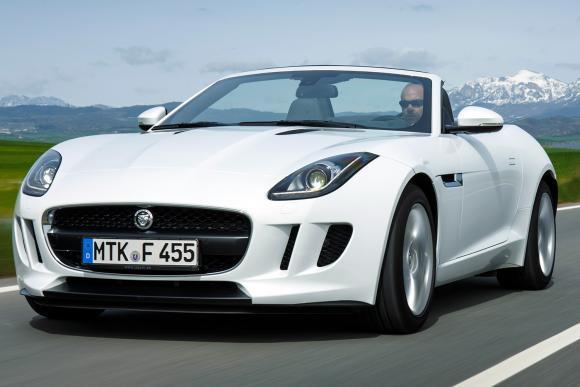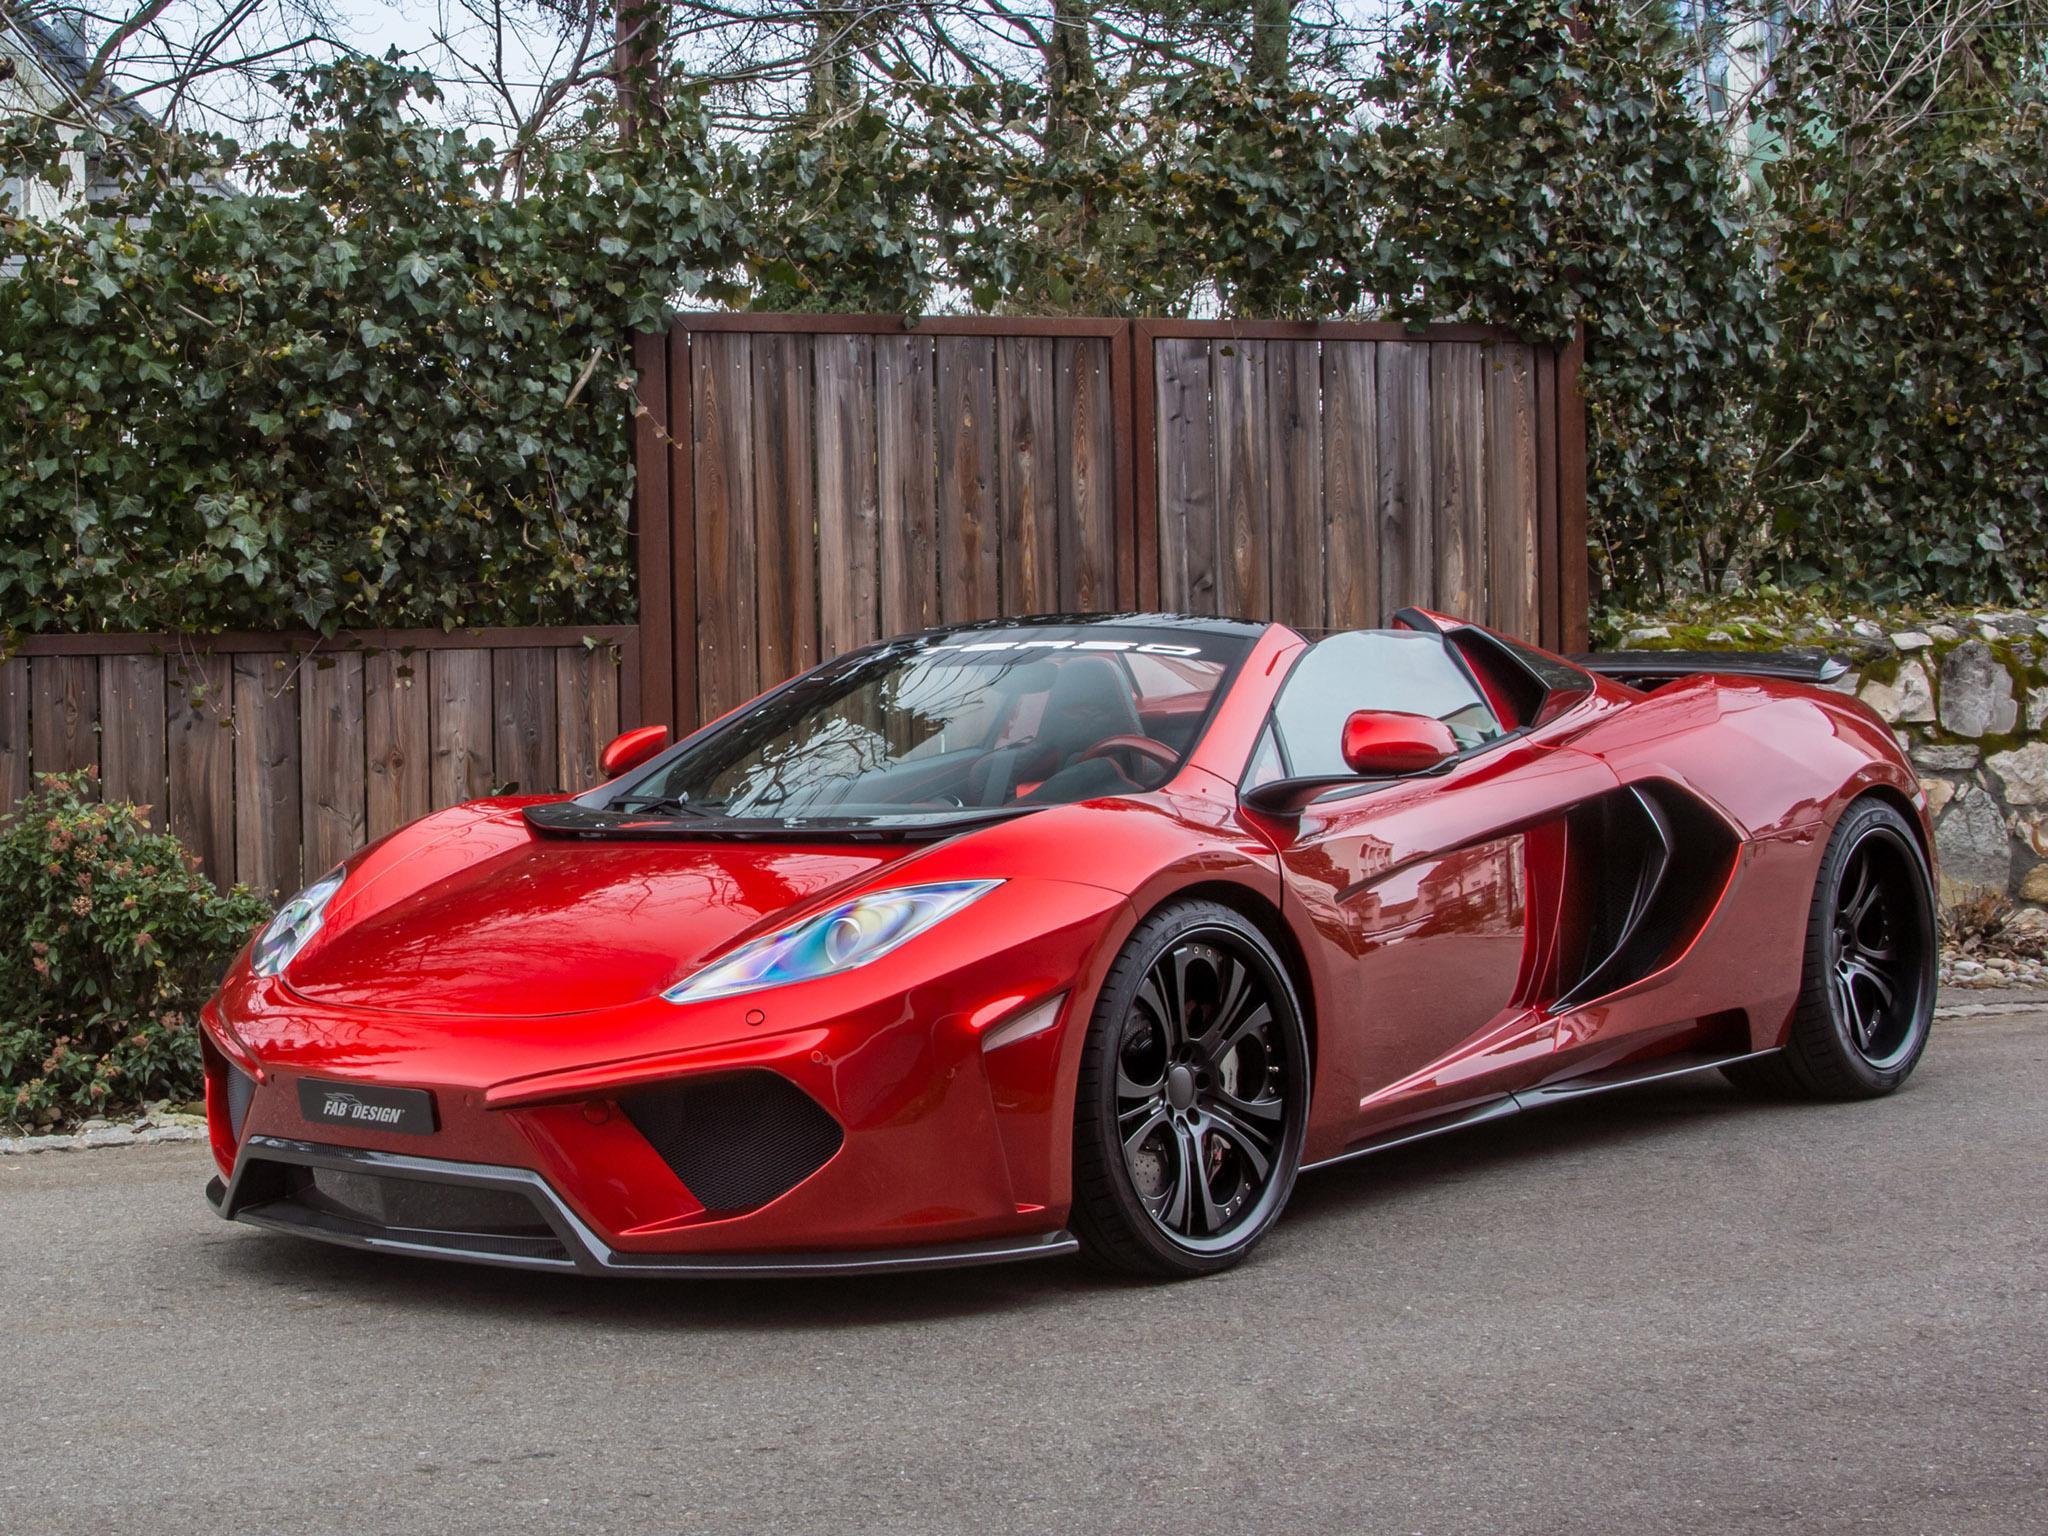The first image is the image on the left, the second image is the image on the right. For the images shown, is this caption "The left image contains a red convertible vehicle." true? Answer yes or no. No. The first image is the image on the left, the second image is the image on the right. Considering the images on both sides, is "The left image features a red convertible car with its top down" valid? Answer yes or no. No. 